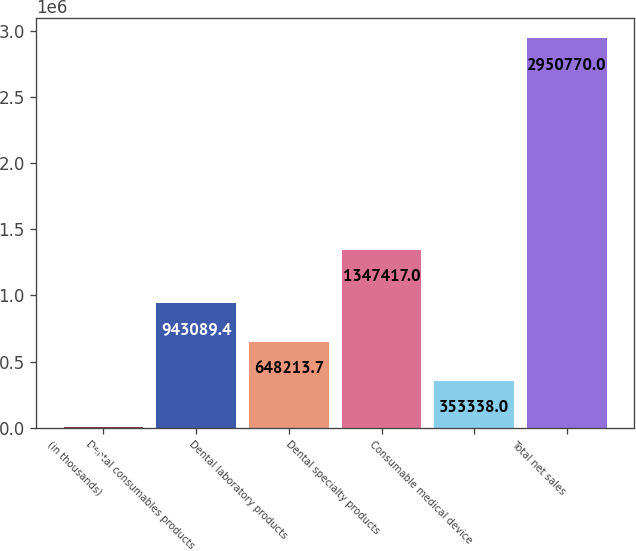Convert chart. <chart><loc_0><loc_0><loc_500><loc_500><bar_chart><fcel>(in thousands)<fcel>Dental consumables products<fcel>Dental laboratory products<fcel>Dental specialty products<fcel>Consumable medical device<fcel>Total net sales<nl><fcel>2013<fcel>943089<fcel>648214<fcel>1.34742e+06<fcel>353338<fcel>2.95077e+06<nl></chart> 